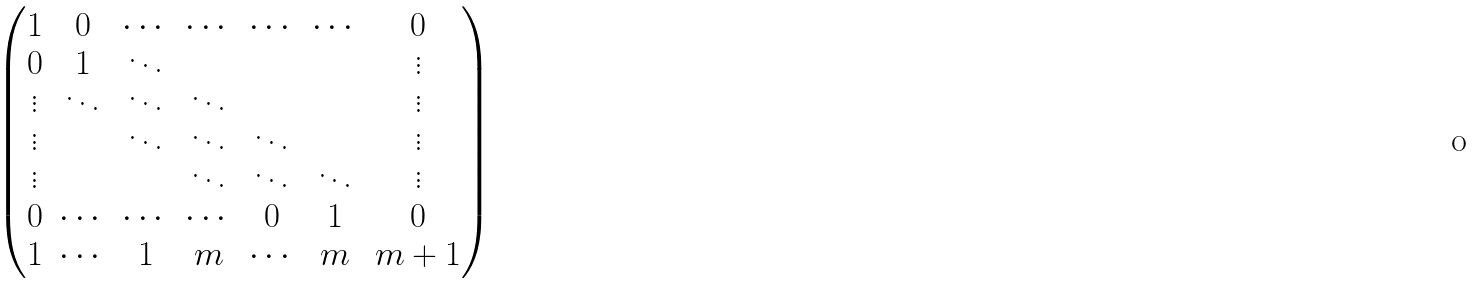<formula> <loc_0><loc_0><loc_500><loc_500>\begin{pmatrix} 1 & 0 & \cdots & \cdots & \cdots & \cdots & 0 \\ 0 & 1 & \ddots & & & & \vdots \\ \vdots & \ddots & \ddots & \ddots & & & \vdots \\ \vdots & & \ddots & \ddots & \ddots & & \vdots \\ \vdots & & & \ddots & \ddots & \ddots & \vdots \\ 0 & \cdots & \cdots & \cdots & 0 & 1 & 0 \\ 1 & \cdots & 1 & m & \cdots & m & m + 1 \end{pmatrix}</formula> 